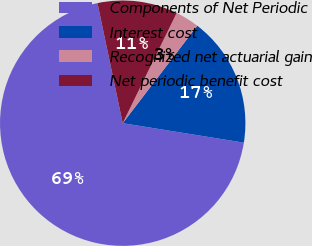<chart> <loc_0><loc_0><loc_500><loc_500><pie_chart><fcel>Components of Net Periodic<fcel>Interest cost<fcel>Recognized net actuarial gain<fcel>Net periodic benefit cost<nl><fcel>69.17%<fcel>17.15%<fcel>3.14%<fcel>10.55%<nl></chart> 